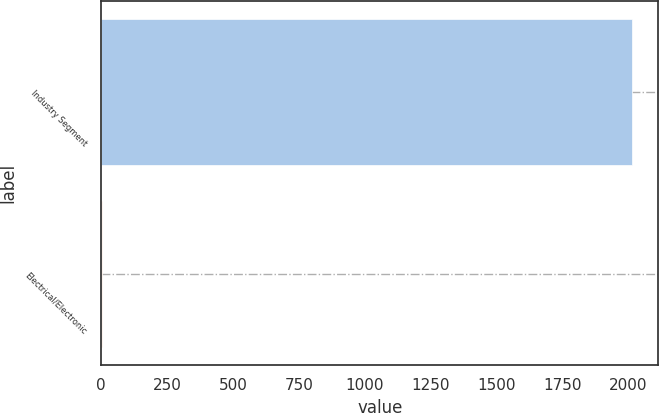Convert chart. <chart><loc_0><loc_0><loc_500><loc_500><bar_chart><fcel>Industry Segment<fcel>Electrical/Electronic<nl><fcel>2013<fcel>4<nl></chart> 